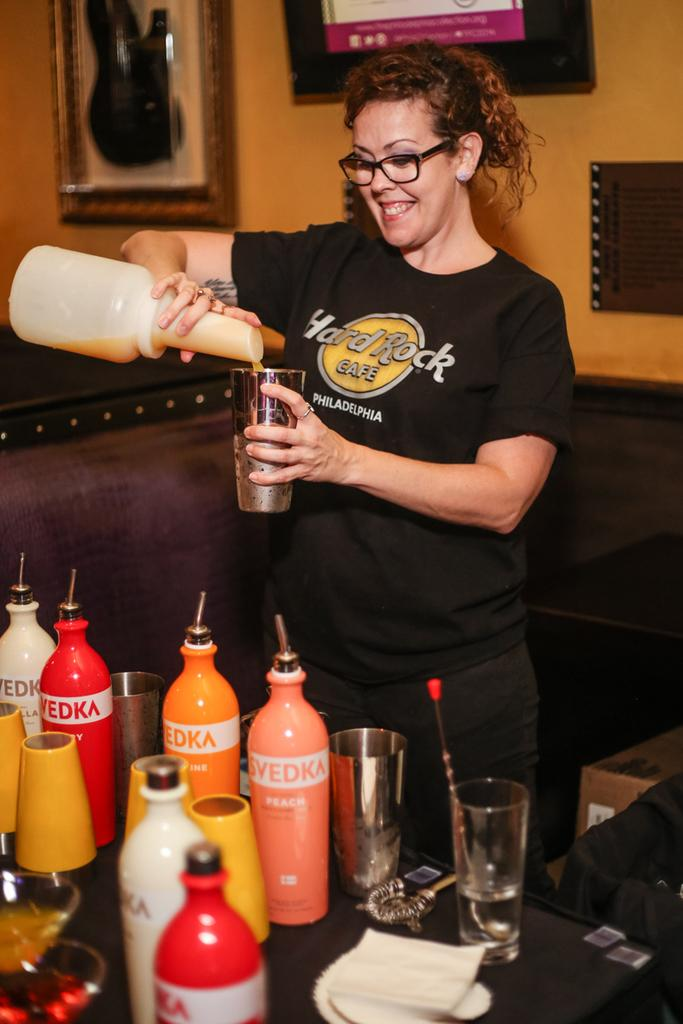<image>
Write a terse but informative summary of the picture. The bartender from Hard Rock Philadelphia pours orange juice into a mixer. 